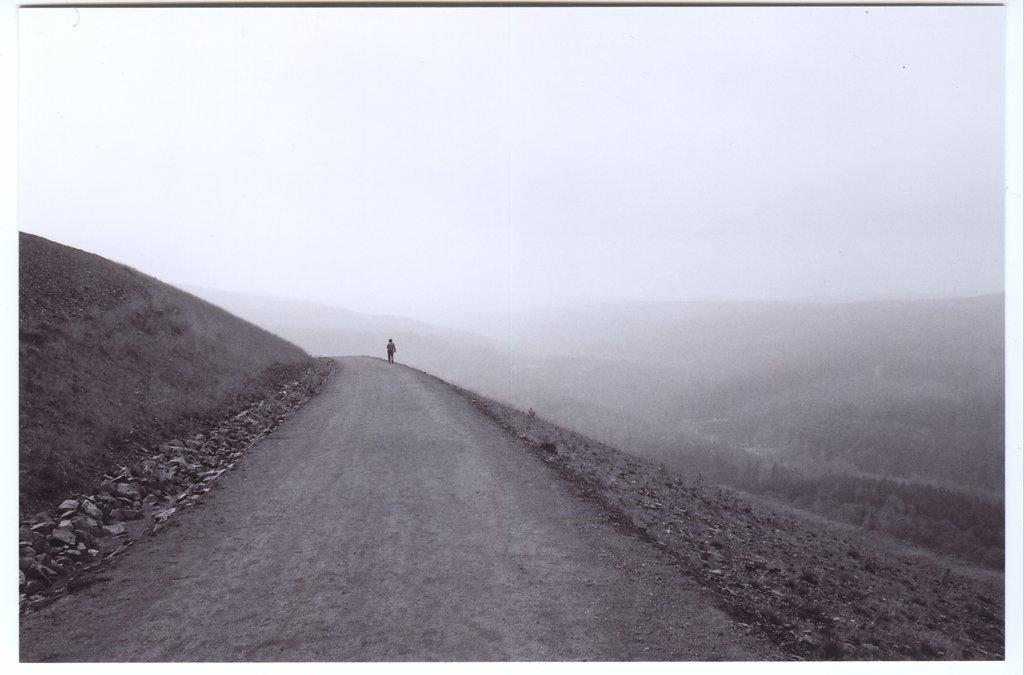What is the person in the image doing? There is a person walking on the road in the image. What can be seen in the background of the image? There are many trees in the image, and the sky is visible. What type of terrain is present in the image? Stones are present in the image. What type of board is the person using to walk on the road? There is no board present in the image; the person is walking on the road itself. 